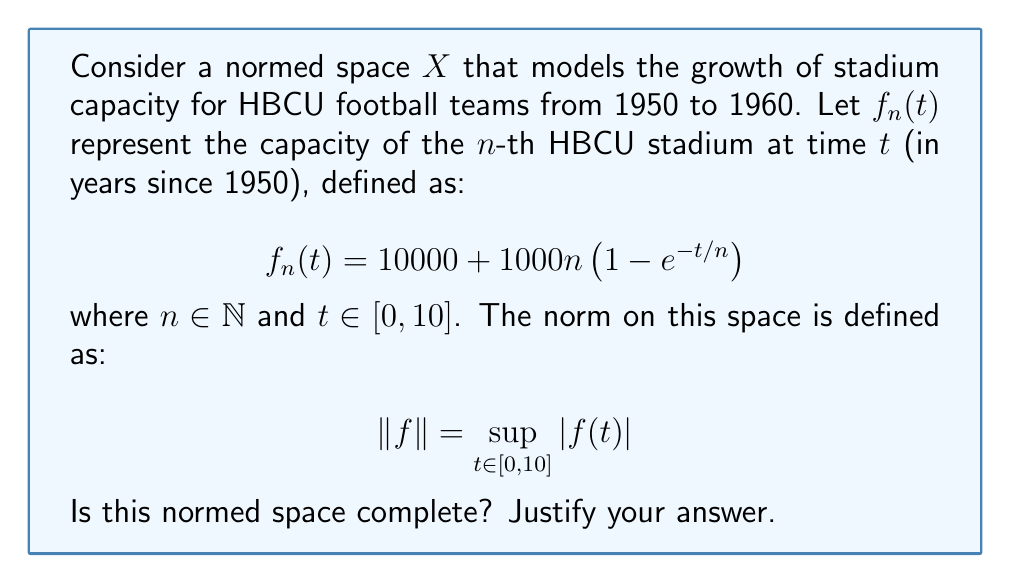Solve this math problem. To determine if the normed space $X$ is complete, we need to check if every Cauchy sequence in $X$ converges to an element in $X$. Let's approach this step-by-step:

1) First, let's examine the behavior of $f_n(t)$ as $n$ approaches infinity:

   $$\lim_{n \to \infty} f_n(t) = \lim_{n \to \infty} \left(10000 + 1000n\left(1 - e^{-t/n}\right)\right)$$

2) Using L'Hôpital's rule:

   $$\lim_{n \to \infty} n\left(1 - e^{-t/n}\right) = \lim_{n \to \infty} \frac{1 - e^{-t/n}}{1/n} = \lim_{n \to \infty} \frac{te^{-t/n}}{-1/n^2} = t$$

3) Therefore:

   $$\lim_{n \to \infty} f_n(t) = 10000 + 1000t$$

4) This limit function, let's call it $f(t) = 10000 + 1000t$, is continuous on $[0,10]$.

5) Now, consider any Cauchy sequence $\{g_k\}$ in $X$. For any $\epsilon > 0$, there exists an $N$ such that for all $m,n > N$:

   $$\|g_m - g_n\| = \sup_{t \in [0,10]} |g_m(t) - g_n(t)| < \epsilon$$

6) This implies that $\{g_k(t)\}$ is a Cauchy sequence in $\mathbb{R}$ for each $t \in [0,10]$.

7) Since $\mathbb{R}$ is complete, $\{g_k(t)\}$ converges pointwise to some function $g(t)$.

8) The uniform convergence of $\{g_k\}$ to $g$ follows from the fact that $\{g_k\}$ is Cauchy in the sup norm.

9) Therefore, $g \in X$ and $\{g_k\}$ converges to $g$ in the norm of $X$.

Thus, every Cauchy sequence in $X$ converges to an element in $X$, which means $X$ is complete.
Answer: Yes, the normed space is complete. 